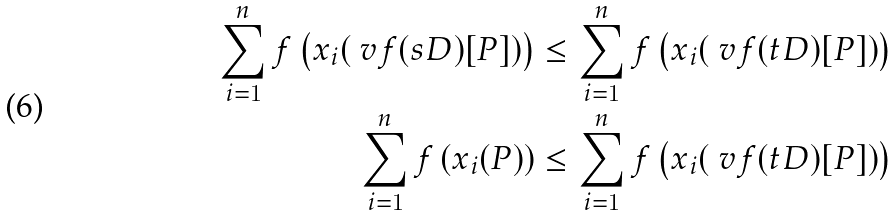<formula> <loc_0><loc_0><loc_500><loc_500>\sum _ { i = 1 } ^ { n } f \left ( x _ { i } ( \ v f ( s D ) [ P ] ) \right ) & \leq \sum _ { i = 1 } ^ { n } f \left ( x _ { i } ( \ v f ( t D ) [ P ] ) \right ) \\ \sum _ { i = 1 } ^ { n } f \left ( x _ { i } ( P ) \right ) & \leq \sum _ { i = 1 } ^ { n } f \left ( x _ { i } ( \ v f ( t D ) [ P ] ) \right )</formula> 